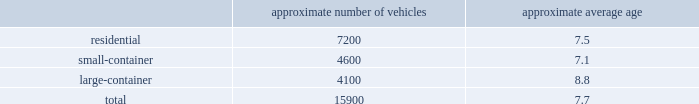Acquire operations and facilities from municipalities and other local governments , as they increasingly seek to raise capital and reduce risk .
We realize synergies from consolidating businesses into our existing operations , whether through acquisitions or public-private partnerships , which allows us to reduce capital expenditures and expenses associated with truck routing , personnel , fleet maintenance , inventories and back-office administration .
Operating model the goal of our operating model pillar is to deliver a consistent , high-quality service to all of our customers through the republic way : one way .
Everywhere .
Every day .
This approach of developing standardized processes with rigorous controls and tracking allows us to leverage our scale and deliver durable operational excellence .
The republic way is the key to harnessing the best of what we do as operators and translating that across all facets of our business .
A key enabler of the republic way is our organizational structure that fosters a high performance culture by maintaining 360-degree accountability and full profit and loss responsibility with local management , supported by a functional structure to provide subject matter expertise .
This structure allows us to take advantage of our scale by coordinating functionally across all of our markets , while empowering local management to respond to unique market dynamics .
We have rolled out several productivity and cost control initiatives designed to deliver the best service possible to our customers in the most efficient and environmentally sound way .
Fleet automation approximately 75% ( 75 % ) of our residential routes have been converted to automated single-driver trucks .
By converting our residential routes to automated service , we reduce labor costs , improve driver productivity , decrease emissions and create a safer work environment for our employees .
Additionally , communities using automated vehicles have higher participation rates in recycling programs , thereby complementing our initiative to expand our recycling capabilities .
Fleet conversion to compressed natural gas ( cng ) approximately 19% ( 19 % ) of our fleet operates on natural gas .
We expect to continue our gradual fleet conversion to cng as part of our ordinary annual fleet replacement process .
We believe a gradual fleet conversion is the most prudent approach to realizing the full value of our previous fleet investments .
Approximately 30% ( 30 % ) of our replacement vehicle purchases during 2017 were cng vehicles .
We believe using cng vehicles provides us a competitive advantage in communities with strict clean emission initiatives that focus on protecting the environment .
Although upfront capital costs are higher , using cng reduces our overall fleet operating costs through lower fuel expenses .
As of december 31 , 2017 , we operated 37 cng fueling stations .
Standardized maintenance based on an industry trade publication , we operate the seventh largest vocational fleet in the united states .
As of december 31 , 2017 , our average fleet age in years , by line of business , was as follows : approximate number of vehicles approximate average age .

What is the approximately number of vehicles that were converted to compressed natural gas? 
Rationale: the approximate number of vehicles that were converted to compressed natural gas was 3021
Computations: (15900 * 19%)
Answer: 3021.0. 